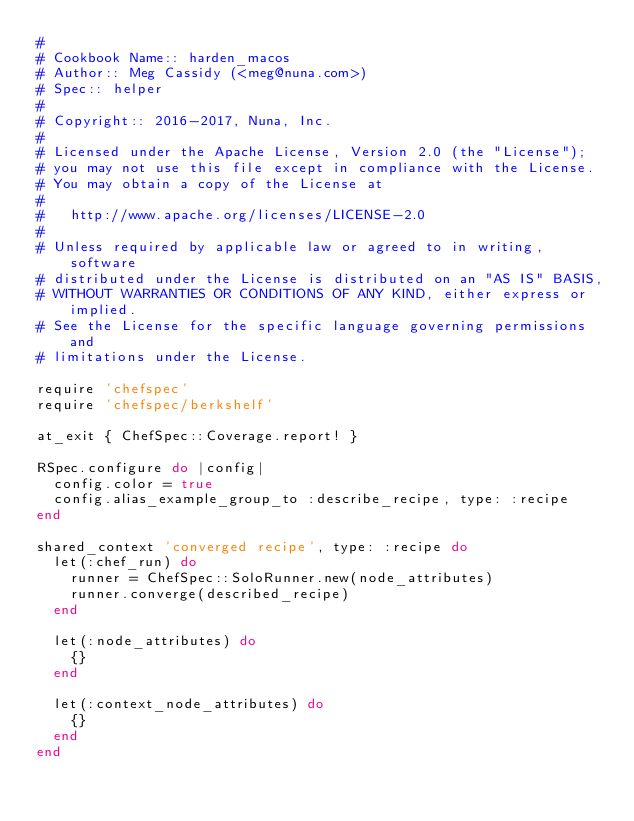Convert code to text. <code><loc_0><loc_0><loc_500><loc_500><_Ruby_>#
# Cookbook Name:: harden_macos
# Author:: Meg Cassidy (<meg@nuna.com>)
# Spec:: helper
#
# Copyright:: 2016-2017, Nuna, Inc.
#
# Licensed under the Apache License, Version 2.0 (the "License");
# you may not use this file except in compliance with the License.
# You may obtain a copy of the License at
#
#   http://www.apache.org/licenses/LICENSE-2.0
#
# Unless required by applicable law or agreed to in writing, software
# distributed under the License is distributed on an "AS IS" BASIS,
# WITHOUT WARRANTIES OR CONDITIONS OF ANY KIND, either express or implied.
# See the License for the specific language governing permissions and
# limitations under the License.

require 'chefspec'
require 'chefspec/berkshelf'

at_exit { ChefSpec::Coverage.report! }

RSpec.configure do |config|
  config.color = true
  config.alias_example_group_to :describe_recipe, type: :recipe
end

shared_context 'converged recipe', type: :recipe do
  let(:chef_run) do
    runner = ChefSpec::SoloRunner.new(node_attributes)
    runner.converge(described_recipe)
  end

  let(:node_attributes) do
    {}
  end

  let(:context_node_attributes) do
    {}
  end
end
</code> 